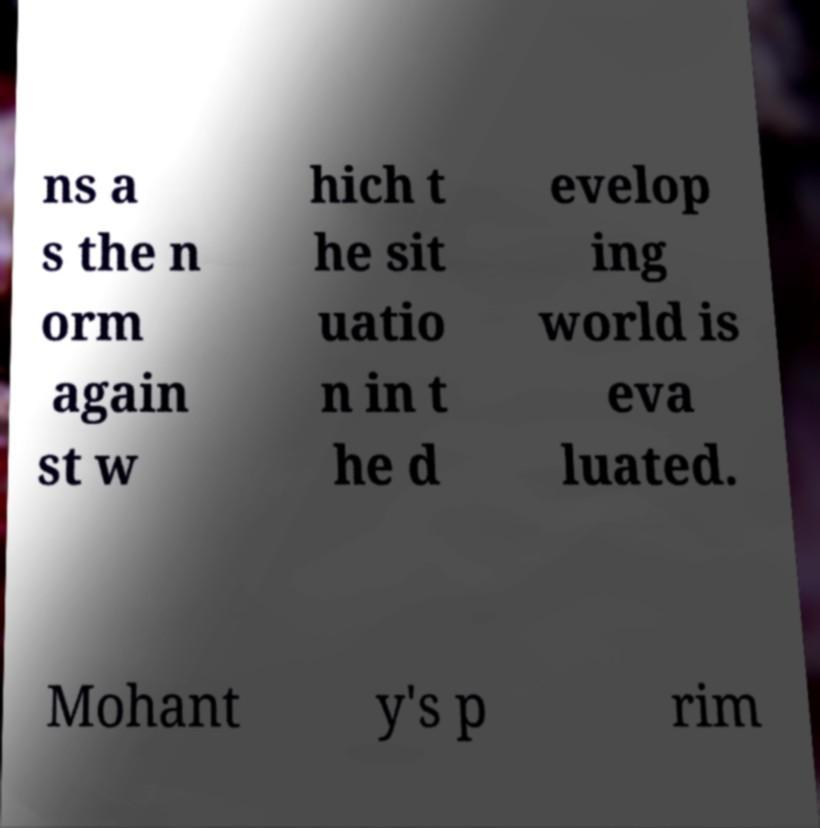Can you accurately transcribe the text from the provided image for me? ns a s the n orm again st w hich t he sit uatio n in t he d evelop ing world is eva luated. Mohant y's p rim 